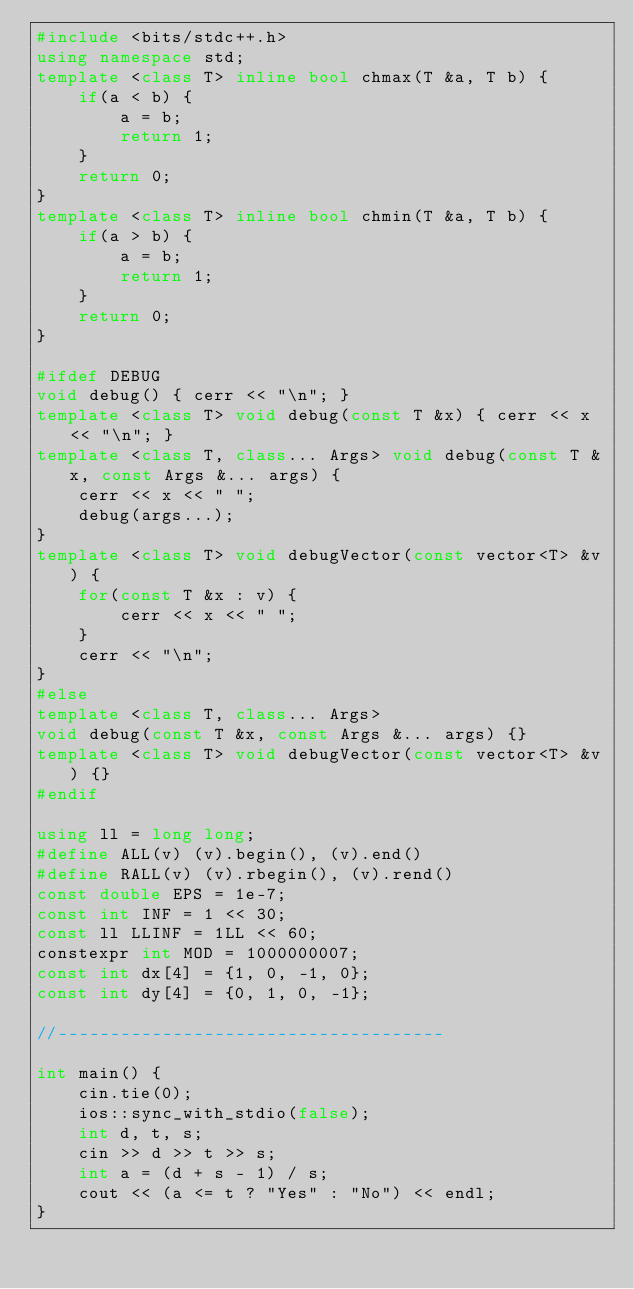Convert code to text. <code><loc_0><loc_0><loc_500><loc_500><_C++_>#include <bits/stdc++.h>
using namespace std;
template <class T> inline bool chmax(T &a, T b) {
    if(a < b) {
        a = b;
        return 1;
    }
    return 0;
}
template <class T> inline bool chmin(T &a, T b) {
    if(a > b) {
        a = b;
        return 1;
    }
    return 0;
}

#ifdef DEBUG
void debug() { cerr << "\n"; }
template <class T> void debug(const T &x) { cerr << x << "\n"; }
template <class T, class... Args> void debug(const T &x, const Args &... args) {
    cerr << x << " ";
    debug(args...);
}
template <class T> void debugVector(const vector<T> &v) {
    for(const T &x : v) {
        cerr << x << " ";
    }
    cerr << "\n";
}
#else
template <class T, class... Args>
void debug(const T &x, const Args &... args) {}
template <class T> void debugVector(const vector<T> &v) {}
#endif

using ll = long long;
#define ALL(v) (v).begin(), (v).end()
#define RALL(v) (v).rbegin(), (v).rend()
const double EPS = 1e-7;
const int INF = 1 << 30;
const ll LLINF = 1LL << 60;
constexpr int MOD = 1000000007;
const int dx[4] = {1, 0, -1, 0};
const int dy[4] = {0, 1, 0, -1};

//-------------------------------------

int main() {
    cin.tie(0);
    ios::sync_with_stdio(false);
    int d, t, s;
    cin >> d >> t >> s;
    int a = (d + s - 1) / s;
    cout << (a <= t ? "Yes" : "No") << endl;
}</code> 